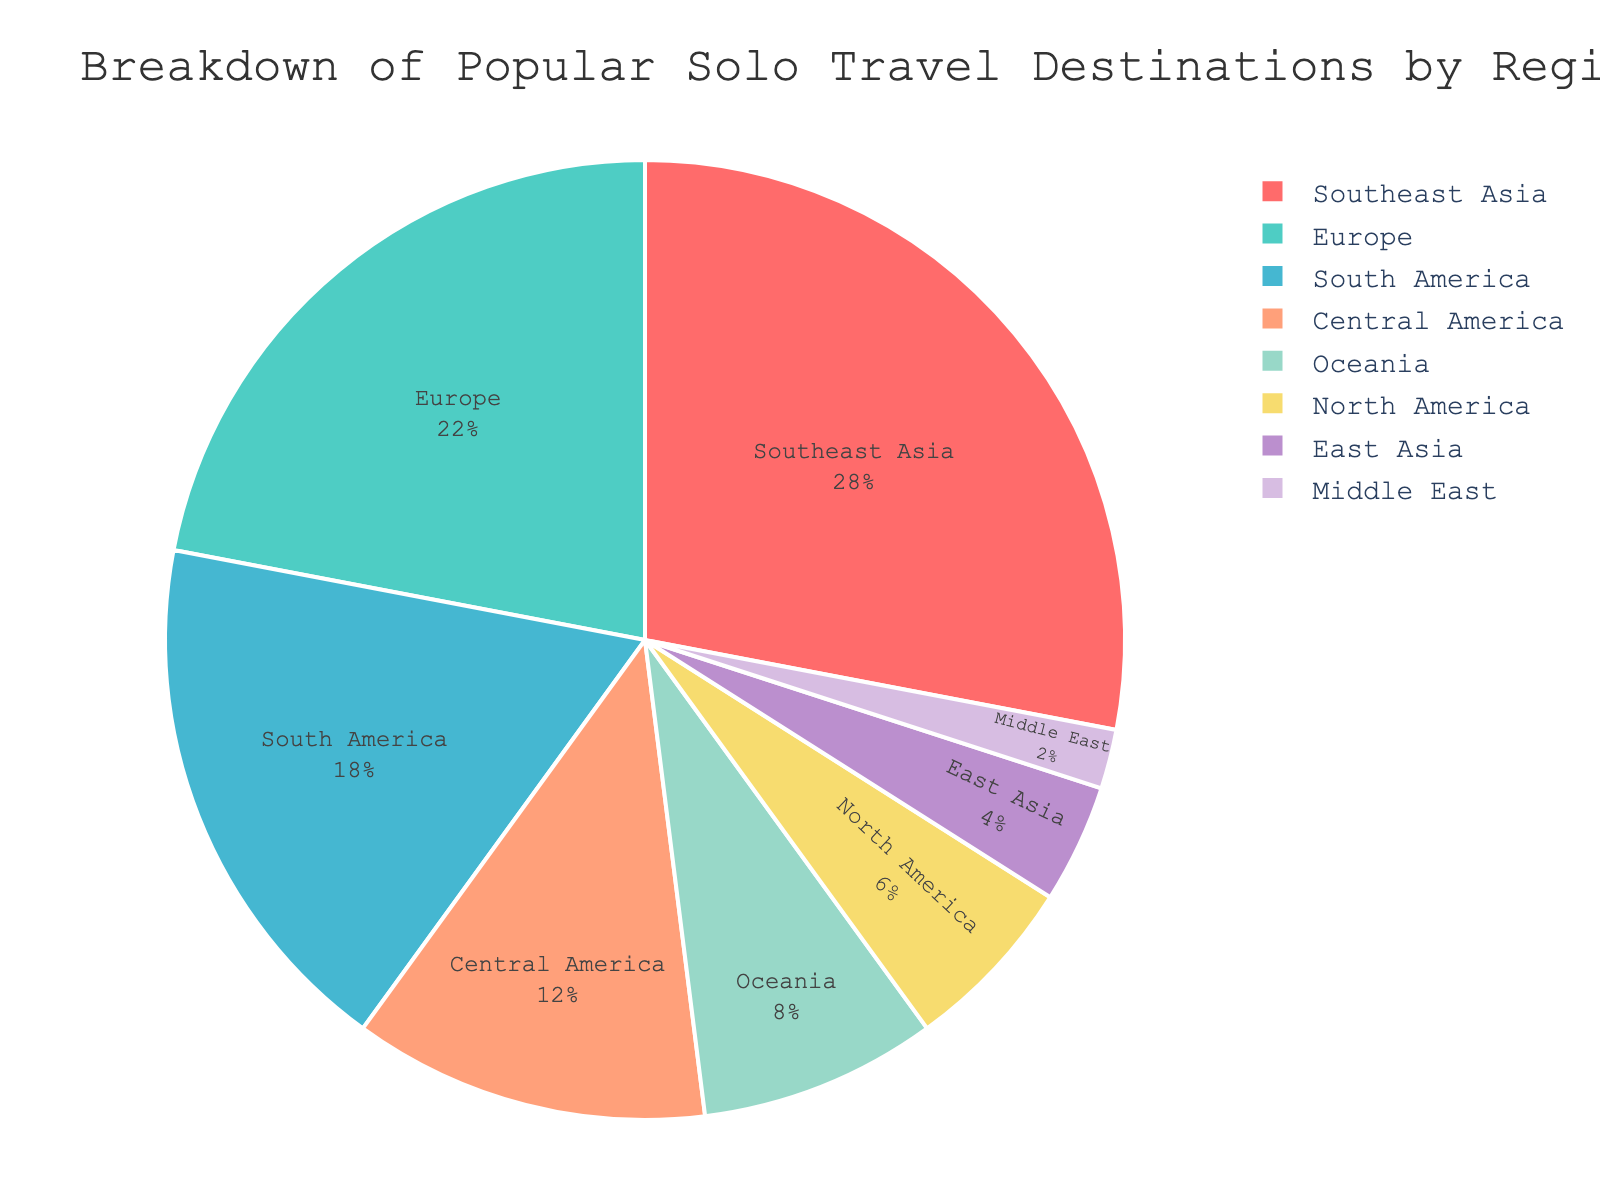What is the most popular solo travel destination region? The region with the highest percentage in the pie chart indicates the most popular solo travel destination region. According to the chart, Southeast Asia has the highest percentage.
Answer: Southeast Asia Which regions together make up over half of the popular solo travel destinations? Sum the percentages of the regions from highest to lowest until the cumulative percentage exceeds 50%. Southeast Asia (28%) + Europe (22%) = 50%. Adding South America (18%) makes it 68%, which is above half.
Answer: Southeast Asia, Europe, and South America What is the percentage difference between the most popular and the least popular solo travel destination regions? Identify the most and least popular regions and then calculate the percentage difference between them. Southeast Asia is the most popular at 28%, and the Middle East is the least popular at 2%. The difference is 28% - 2%.
Answer: 26% Are there more popular solo travel destinations in Europe or Oceania? Compare the percentage values for Europe (22%) and Oceania (8%) directly. Europe has a higher percentage than Oceania.
Answer: Europe Which region represents a smaller portion, North America or East Asia? Compare the percentages of North America and East Asia. North America has 6%, while East Asia has 4%.
Answer: East Asia If you combine the percentages of Central America and South America, what do you get? Sum the percentages of Central America (12%) and South America (18%). The combined percentage is 12% + 18%.
Answer: 30% What is the sum of the percentages for the least three popular solo travel destination regions? Identify the three regions with the smallest percentages: Middle East (2%), East Asia (4%), and North America (6%). Sum these amounts: 2% + 4% + 6%.
Answer: 12% Which two regions together make up a similar percentage to Europe? Find a combination of regions whose sum is close to Europe’s percentage (22%). North America (6%) + South America (18%) = 24%, which is close to 22%.
Answer: North America and South America 